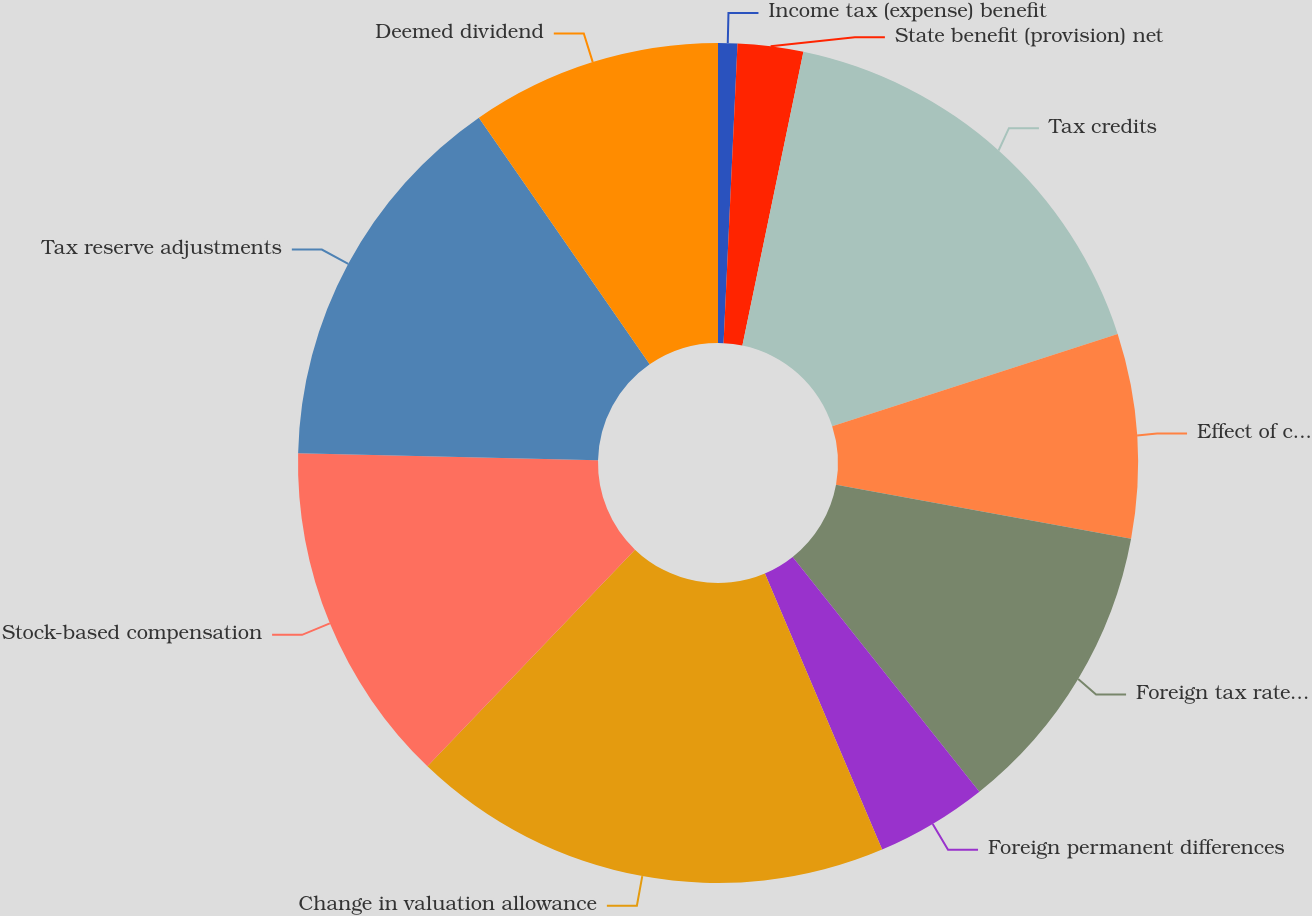Convert chart. <chart><loc_0><loc_0><loc_500><loc_500><pie_chart><fcel>Income tax (expense) benefit<fcel>State benefit (provision) net<fcel>Tax credits<fcel>Effect of changes in income<fcel>Foreign tax rate difference<fcel>Foreign permanent differences<fcel>Change in valuation allowance<fcel>Stock-based compensation<fcel>Tax reserve adjustments<fcel>Deemed dividend<nl><fcel>0.74%<fcel>2.52%<fcel>16.77%<fcel>7.86%<fcel>11.42%<fcel>4.3%<fcel>18.55%<fcel>13.21%<fcel>14.99%<fcel>9.64%<nl></chart> 